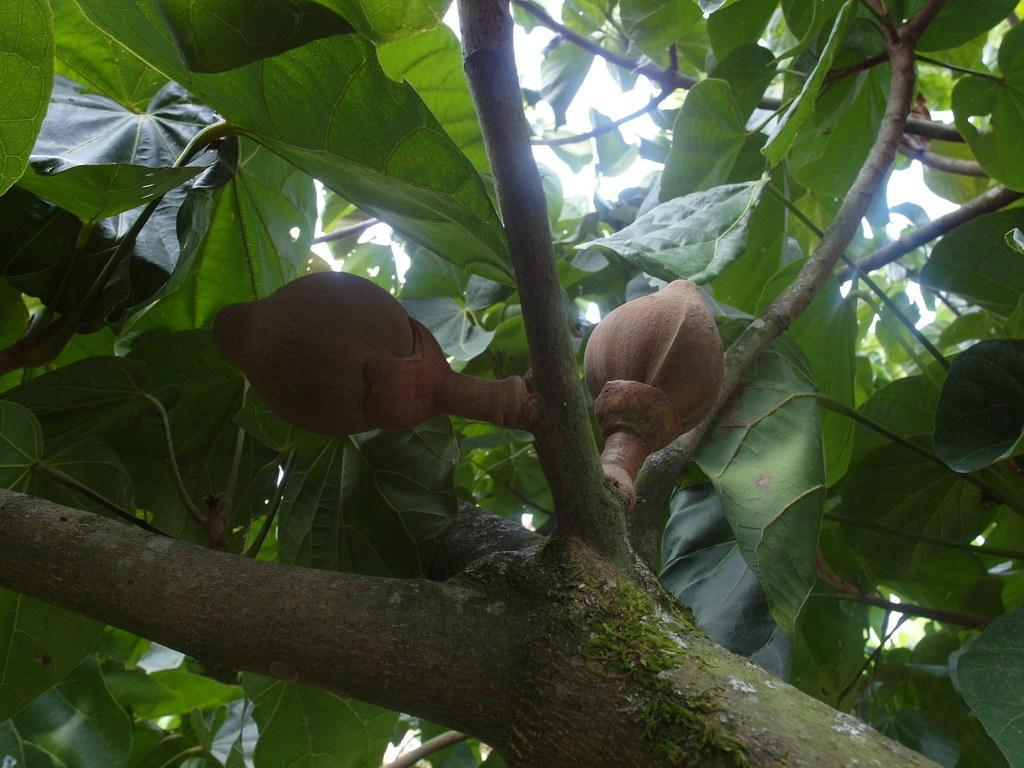Could you give a brief overview of what you see in this image? At the bottom of this image, there are branches having two fruits and green color leaves. In the background, there are green color leaves and there is sky. 